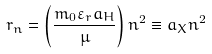Convert formula to latex. <formula><loc_0><loc_0><loc_500><loc_500>r _ { n } = \left ( { \frac { m _ { 0 } \varepsilon _ { r } a _ { H } } { \mu } } \right ) n ^ { 2 } \equiv a _ { X } n ^ { 2 }</formula> 